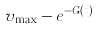Convert formula to latex. <formula><loc_0><loc_0><loc_500><loc_500>v _ { \max } - e ^ { - G ( t ) }</formula> 